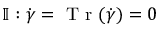Convert formula to latex. <formula><loc_0><loc_0><loc_500><loc_500>\mathbb { I } \colon \dot { \gamma } = T r ( \dot { \gamma } ) = 0</formula> 